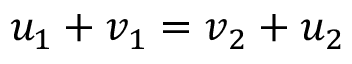Convert formula to latex. <formula><loc_0><loc_0><loc_500><loc_500>u _ { 1 } + v _ { 1 } = v _ { 2 } + u _ { 2 }</formula> 